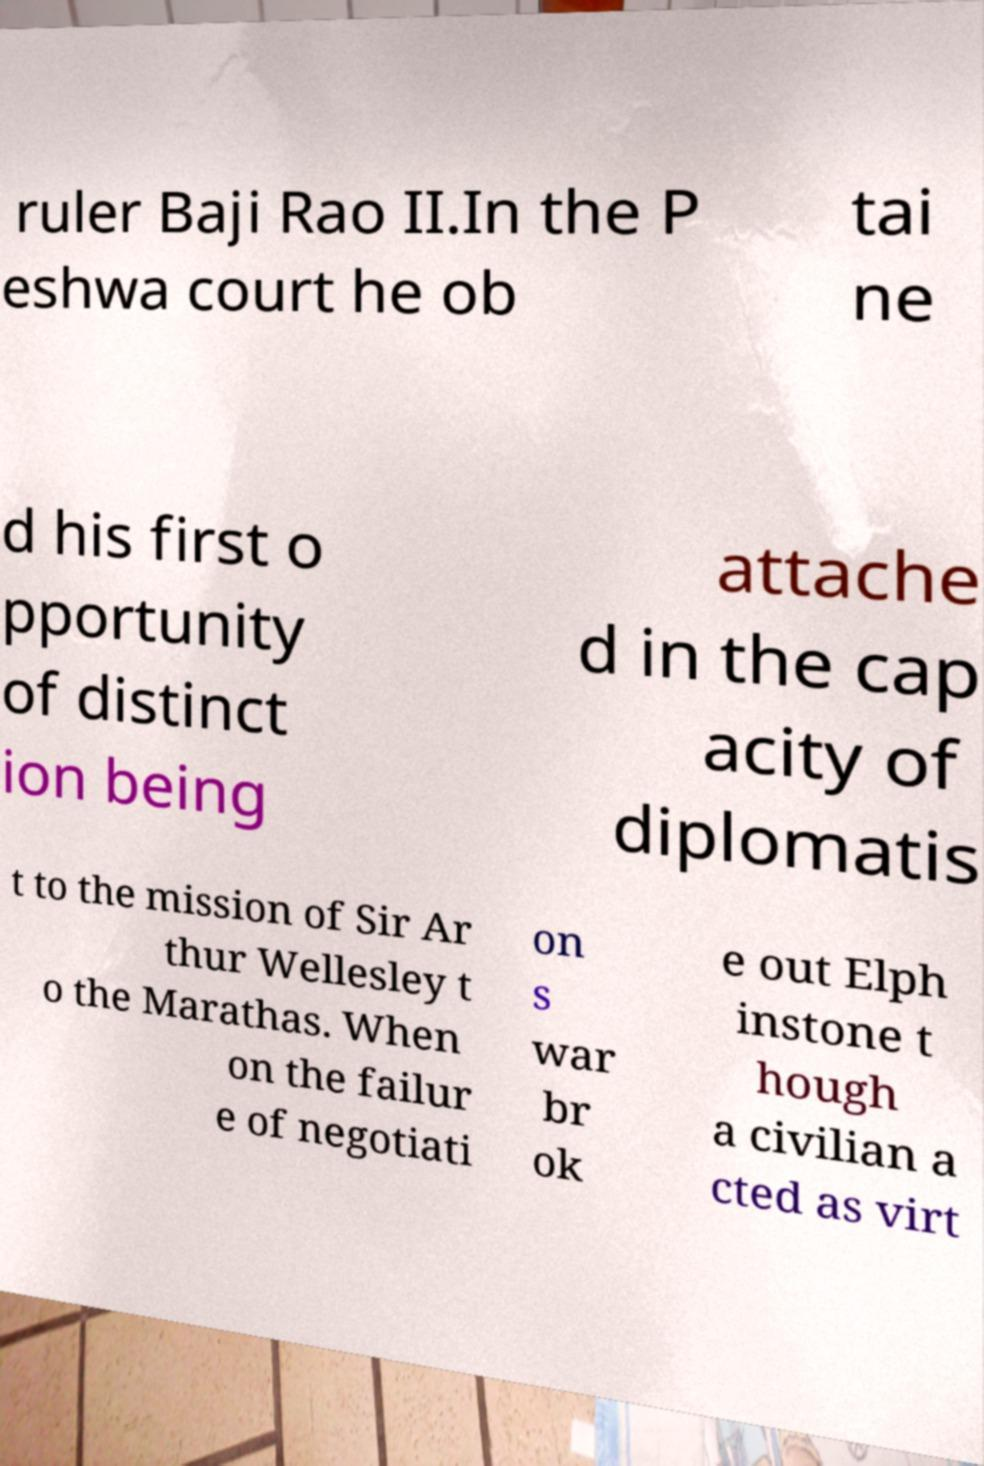Can you accurately transcribe the text from the provided image for me? ruler Baji Rao II.In the P eshwa court he ob tai ne d his first o pportunity of distinct ion being attache d in the cap acity of diplomatis t to the mission of Sir Ar thur Wellesley t o the Marathas. When on the failur e of negotiati on s war br ok e out Elph instone t hough a civilian a cted as virt 